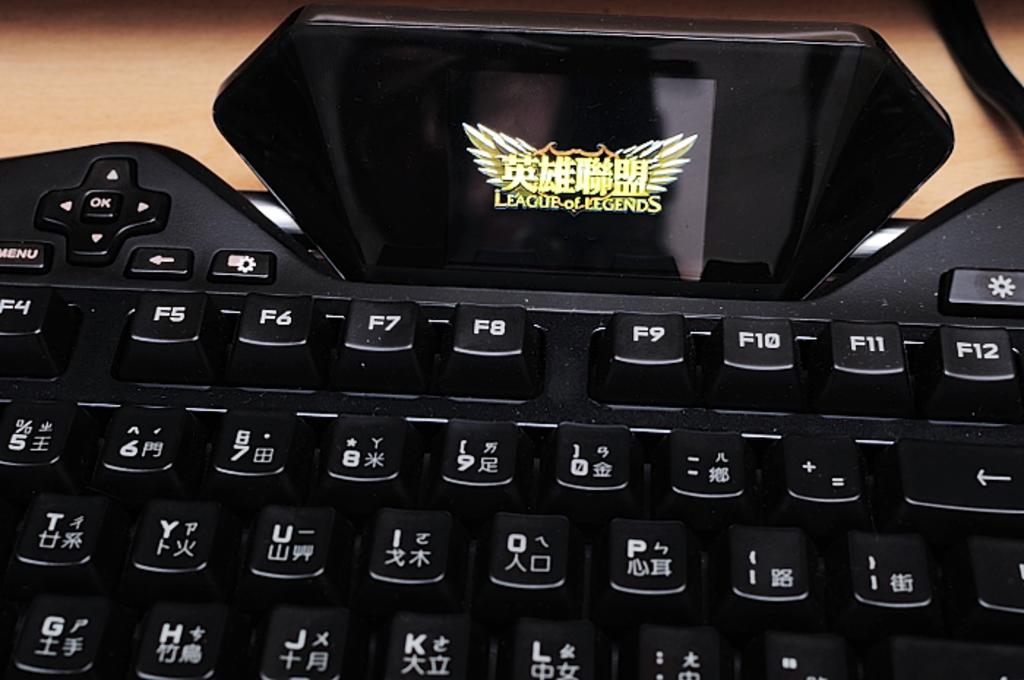Is league of legends played on that miniscule screen?
Your response must be concise. Yes. What language is the keys in?
Offer a terse response. Unanswerable. 